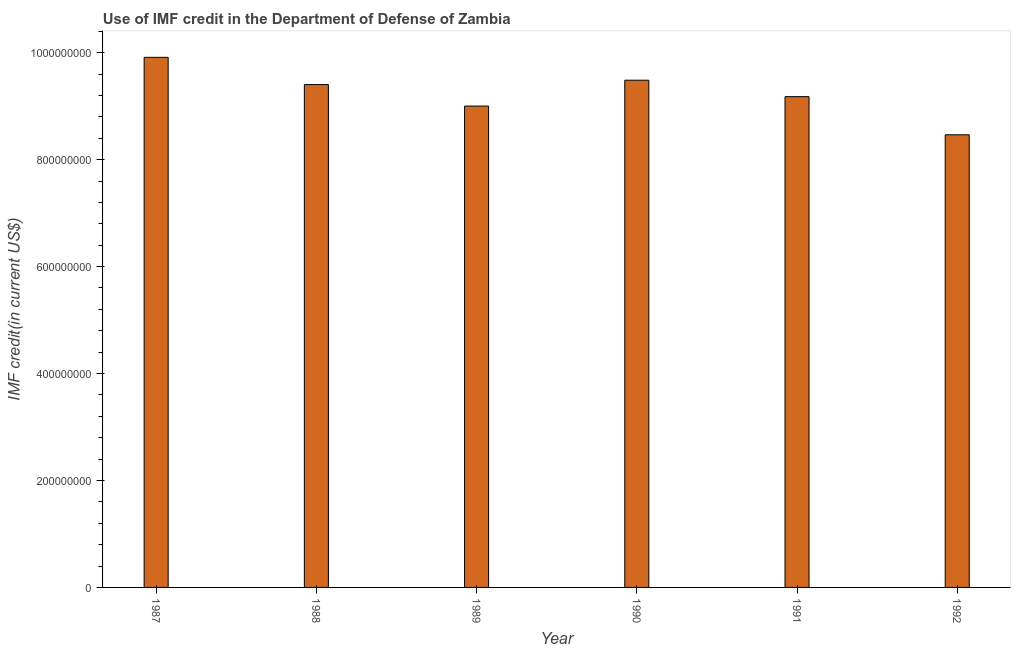Does the graph contain any zero values?
Ensure brevity in your answer.  No. What is the title of the graph?
Provide a short and direct response. Use of IMF credit in the Department of Defense of Zambia. What is the label or title of the Y-axis?
Your answer should be very brief. IMF credit(in current US$). What is the use of imf credit in dod in 1992?
Offer a terse response. 8.46e+08. Across all years, what is the maximum use of imf credit in dod?
Keep it short and to the point. 9.91e+08. Across all years, what is the minimum use of imf credit in dod?
Your answer should be very brief. 8.46e+08. What is the sum of the use of imf credit in dod?
Offer a very short reply. 5.54e+09. What is the difference between the use of imf credit in dod in 1988 and 1991?
Provide a succinct answer. 2.26e+07. What is the average use of imf credit in dod per year?
Give a very brief answer. 9.24e+08. What is the median use of imf credit in dod?
Offer a very short reply. 9.29e+08. Do a majority of the years between 1987 and 1988 (inclusive) have use of imf credit in dod greater than 480000000 US$?
Your answer should be very brief. Yes. What is the ratio of the use of imf credit in dod in 1988 to that in 1992?
Make the answer very short. 1.11. Is the use of imf credit in dod in 1988 less than that in 1991?
Make the answer very short. No. What is the difference between the highest and the second highest use of imf credit in dod?
Your response must be concise. 4.28e+07. Is the sum of the use of imf credit in dod in 1989 and 1992 greater than the maximum use of imf credit in dod across all years?
Offer a very short reply. Yes. What is the difference between the highest and the lowest use of imf credit in dod?
Your answer should be compact. 1.45e+08. In how many years, is the use of imf credit in dod greater than the average use of imf credit in dod taken over all years?
Your response must be concise. 3. How many bars are there?
Your answer should be compact. 6. What is the difference between two consecutive major ticks on the Y-axis?
Offer a terse response. 2.00e+08. What is the IMF credit(in current US$) of 1987?
Offer a very short reply. 9.91e+08. What is the IMF credit(in current US$) of 1988?
Provide a succinct answer. 9.40e+08. What is the IMF credit(in current US$) in 1989?
Your answer should be very brief. 9.00e+08. What is the IMF credit(in current US$) of 1990?
Ensure brevity in your answer.  9.49e+08. What is the IMF credit(in current US$) in 1991?
Offer a very short reply. 9.18e+08. What is the IMF credit(in current US$) of 1992?
Your answer should be compact. 8.46e+08. What is the difference between the IMF credit(in current US$) in 1987 and 1988?
Offer a terse response. 5.10e+07. What is the difference between the IMF credit(in current US$) in 1987 and 1989?
Your response must be concise. 9.12e+07. What is the difference between the IMF credit(in current US$) in 1987 and 1990?
Your answer should be compact. 4.28e+07. What is the difference between the IMF credit(in current US$) in 1987 and 1991?
Offer a terse response. 7.35e+07. What is the difference between the IMF credit(in current US$) in 1987 and 1992?
Ensure brevity in your answer.  1.45e+08. What is the difference between the IMF credit(in current US$) in 1988 and 1989?
Make the answer very short. 4.02e+07. What is the difference between the IMF credit(in current US$) in 1988 and 1990?
Your answer should be compact. -8.18e+06. What is the difference between the IMF credit(in current US$) in 1988 and 1991?
Keep it short and to the point. 2.26e+07. What is the difference between the IMF credit(in current US$) in 1988 and 1992?
Ensure brevity in your answer.  9.39e+07. What is the difference between the IMF credit(in current US$) in 1989 and 1990?
Make the answer very short. -4.84e+07. What is the difference between the IMF credit(in current US$) in 1989 and 1991?
Your answer should be very brief. -1.76e+07. What is the difference between the IMF credit(in current US$) in 1989 and 1992?
Your answer should be very brief. 5.37e+07. What is the difference between the IMF credit(in current US$) in 1990 and 1991?
Offer a very short reply. 3.08e+07. What is the difference between the IMF credit(in current US$) in 1990 and 1992?
Your answer should be compact. 1.02e+08. What is the difference between the IMF credit(in current US$) in 1991 and 1992?
Offer a terse response. 7.13e+07. What is the ratio of the IMF credit(in current US$) in 1987 to that in 1988?
Offer a terse response. 1.05. What is the ratio of the IMF credit(in current US$) in 1987 to that in 1989?
Provide a short and direct response. 1.1. What is the ratio of the IMF credit(in current US$) in 1987 to that in 1990?
Offer a terse response. 1.04. What is the ratio of the IMF credit(in current US$) in 1987 to that in 1992?
Keep it short and to the point. 1.17. What is the ratio of the IMF credit(in current US$) in 1988 to that in 1989?
Provide a short and direct response. 1.04. What is the ratio of the IMF credit(in current US$) in 1988 to that in 1990?
Ensure brevity in your answer.  0.99. What is the ratio of the IMF credit(in current US$) in 1988 to that in 1992?
Offer a very short reply. 1.11. What is the ratio of the IMF credit(in current US$) in 1989 to that in 1990?
Keep it short and to the point. 0.95. What is the ratio of the IMF credit(in current US$) in 1989 to that in 1992?
Your answer should be compact. 1.06. What is the ratio of the IMF credit(in current US$) in 1990 to that in 1991?
Ensure brevity in your answer.  1.03. What is the ratio of the IMF credit(in current US$) in 1990 to that in 1992?
Make the answer very short. 1.12. What is the ratio of the IMF credit(in current US$) in 1991 to that in 1992?
Offer a very short reply. 1.08. 